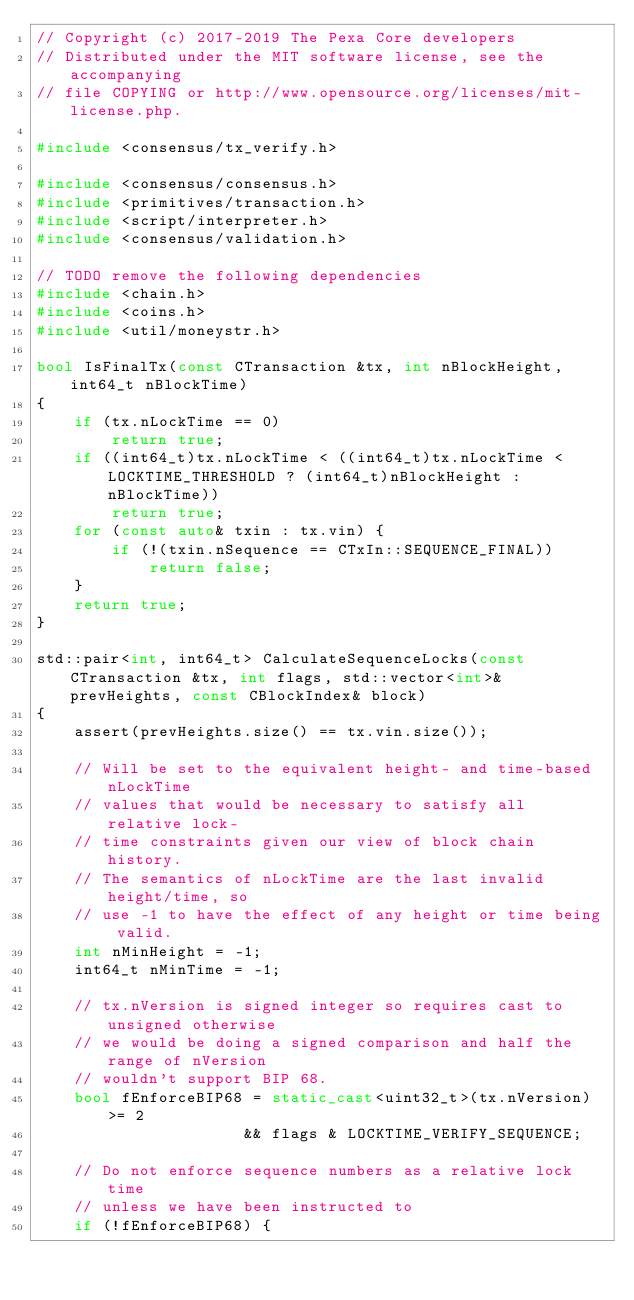Convert code to text. <code><loc_0><loc_0><loc_500><loc_500><_C++_>// Copyright (c) 2017-2019 The Pexa Core developers
// Distributed under the MIT software license, see the accompanying
// file COPYING or http://www.opensource.org/licenses/mit-license.php.

#include <consensus/tx_verify.h>

#include <consensus/consensus.h>
#include <primitives/transaction.h>
#include <script/interpreter.h>
#include <consensus/validation.h>

// TODO remove the following dependencies
#include <chain.h>
#include <coins.h>
#include <util/moneystr.h>

bool IsFinalTx(const CTransaction &tx, int nBlockHeight, int64_t nBlockTime)
{
    if (tx.nLockTime == 0)
        return true;
    if ((int64_t)tx.nLockTime < ((int64_t)tx.nLockTime < LOCKTIME_THRESHOLD ? (int64_t)nBlockHeight : nBlockTime))
        return true;
    for (const auto& txin : tx.vin) {
        if (!(txin.nSequence == CTxIn::SEQUENCE_FINAL))
            return false;
    }
    return true;
}

std::pair<int, int64_t> CalculateSequenceLocks(const CTransaction &tx, int flags, std::vector<int>& prevHeights, const CBlockIndex& block)
{
    assert(prevHeights.size() == tx.vin.size());

    // Will be set to the equivalent height- and time-based nLockTime
    // values that would be necessary to satisfy all relative lock-
    // time constraints given our view of block chain history.
    // The semantics of nLockTime are the last invalid height/time, so
    // use -1 to have the effect of any height or time being valid.
    int nMinHeight = -1;
    int64_t nMinTime = -1;

    // tx.nVersion is signed integer so requires cast to unsigned otherwise
    // we would be doing a signed comparison and half the range of nVersion
    // wouldn't support BIP 68.
    bool fEnforceBIP68 = static_cast<uint32_t>(tx.nVersion) >= 2
                      && flags & LOCKTIME_VERIFY_SEQUENCE;

    // Do not enforce sequence numbers as a relative lock time
    // unless we have been instructed to
    if (!fEnforceBIP68) {</code> 